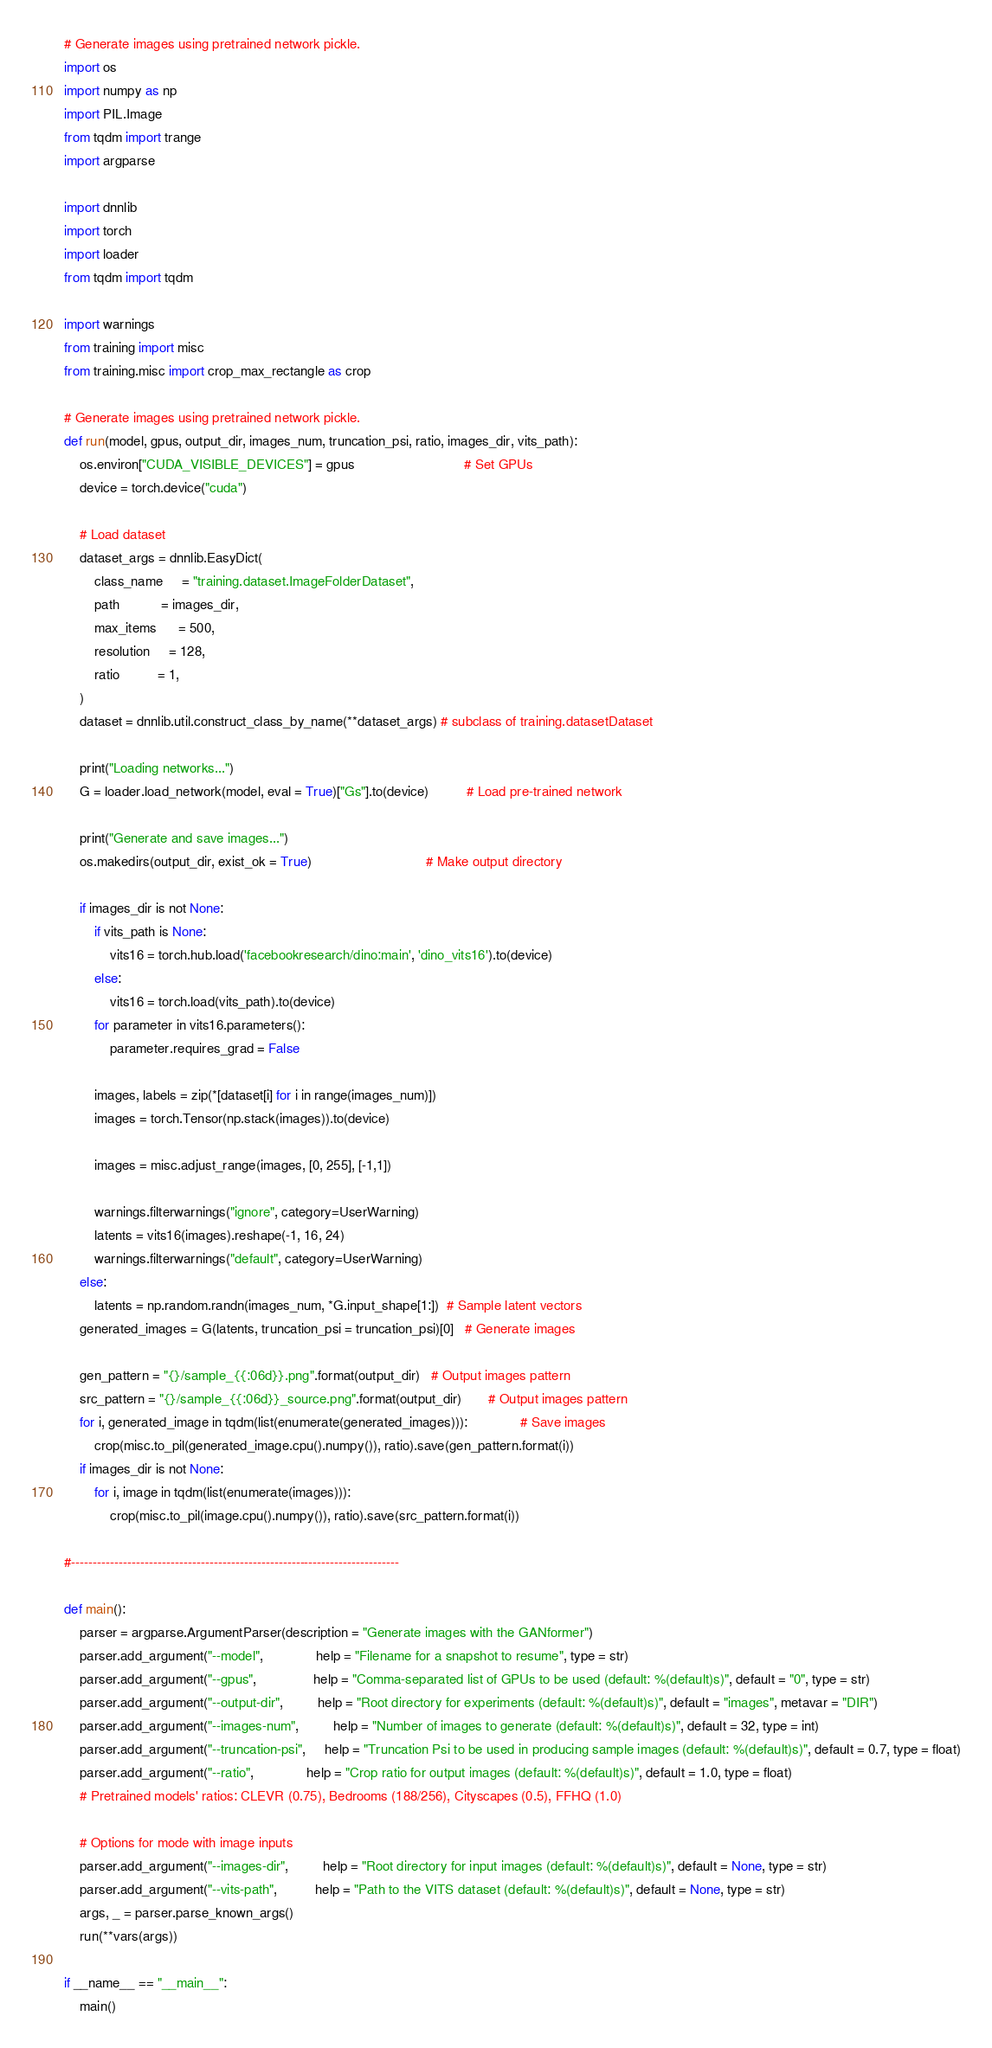Convert code to text. <code><loc_0><loc_0><loc_500><loc_500><_Python_># Generate images using pretrained network pickle.
import os
import numpy as np
import PIL.Image
from tqdm import trange 
import argparse

import dnnlib
import torch
import loader
from tqdm import tqdm

import warnings
from training import misc
from training.misc import crop_max_rectangle as crop

# Generate images using pretrained network pickle.
def run(model, gpus, output_dir, images_num, truncation_psi, ratio, images_dir, vits_path):
    os.environ["CUDA_VISIBLE_DEVICES"] = gpus                             # Set GPUs
    device = torch.device("cuda")

    # Load dataset
    dataset_args = dnnlib.EasyDict(
        class_name     = "training.dataset.ImageFolderDataset", 
        path           = images_dir,
        max_items      = 500, 
        resolution     = 128,
        ratio          = 1,
    )
    dataset = dnnlib.util.construct_class_by_name(**dataset_args) # subclass of training.datasetDataset

    print("Loading networks...")
    G = loader.load_network(model, eval = True)["Gs"].to(device)          # Load pre-trained network

    print("Generate and save images...")
    os.makedirs(output_dir, exist_ok = True)                              # Make output directory

    if images_dir is not None:
        if vits_path is None:
            vits16 = torch.hub.load('facebookresearch/dino:main', 'dino_vits16').to(device)
        else:
            vits16 = torch.load(vits_path).to(device)
        for parameter in vits16.parameters():
            parameter.requires_grad = False

        images, labels = zip(*[dataset[i] for i in range(images_num)])
        images = torch.Tensor(np.stack(images)).to(device)

        images = misc.adjust_range(images, [0, 255], [-1,1])

        warnings.filterwarnings("ignore", category=UserWarning)
        latents = vits16(images).reshape(-1, 16, 24)
        warnings.filterwarnings("default", category=UserWarning)
    else:
        latents = np.random.randn(images_num, *G.input_shape[1:])  # Sample latent vectors
    generated_images = G(latents, truncation_psi = truncation_psi)[0]   # Generate images

    gen_pattern = "{}/sample_{{:06d}}.png".format(output_dir)   # Output images pattern
    src_pattern = "{}/sample_{{:06d}}_source.png".format(output_dir)       # Output images pattern
    for i, generated_image in tqdm(list(enumerate(generated_images))):              # Save images
        crop(misc.to_pil(generated_image.cpu().numpy()), ratio).save(gen_pattern.format(i))
    if images_dir is not None:
        for i, image in tqdm(list(enumerate(images))):
            crop(misc.to_pil(image.cpu().numpy()), ratio).save(src_pattern.format(i))

#----------------------------------------------------------------------------

def main():
    parser = argparse.ArgumentParser(description = "Generate images with the GANformer")
    parser.add_argument("--model",              help = "Filename for a snapshot to resume", type = str)
    parser.add_argument("--gpus",               help = "Comma-separated list of GPUs to be used (default: %(default)s)", default = "0", type = str)
    parser.add_argument("--output-dir",         help = "Root directory for experiments (default: %(default)s)", default = "images", metavar = "DIR")
    parser.add_argument("--images-num",         help = "Number of images to generate (default: %(default)s)", default = 32, type = int)
    parser.add_argument("--truncation-psi",     help = "Truncation Psi to be used in producing sample images (default: %(default)s)", default = 0.7, type = float)
    parser.add_argument("--ratio",              help = "Crop ratio for output images (default: %(default)s)", default = 1.0, type = float)
    # Pretrained models' ratios: CLEVR (0.75), Bedrooms (188/256), Cityscapes (0.5), FFHQ (1.0)

    # Options for mode with image inputs
    parser.add_argument("--images-dir",         help = "Root directory for input images (default: %(default)s)", default = None, type = str)
    parser.add_argument("--vits-path",          help = "Path to the VITS dataset (default: %(default)s)", default = None, type = str)
    args, _ = parser.parse_known_args()
    run(**vars(args))

if __name__ == "__main__":
    main()
</code> 